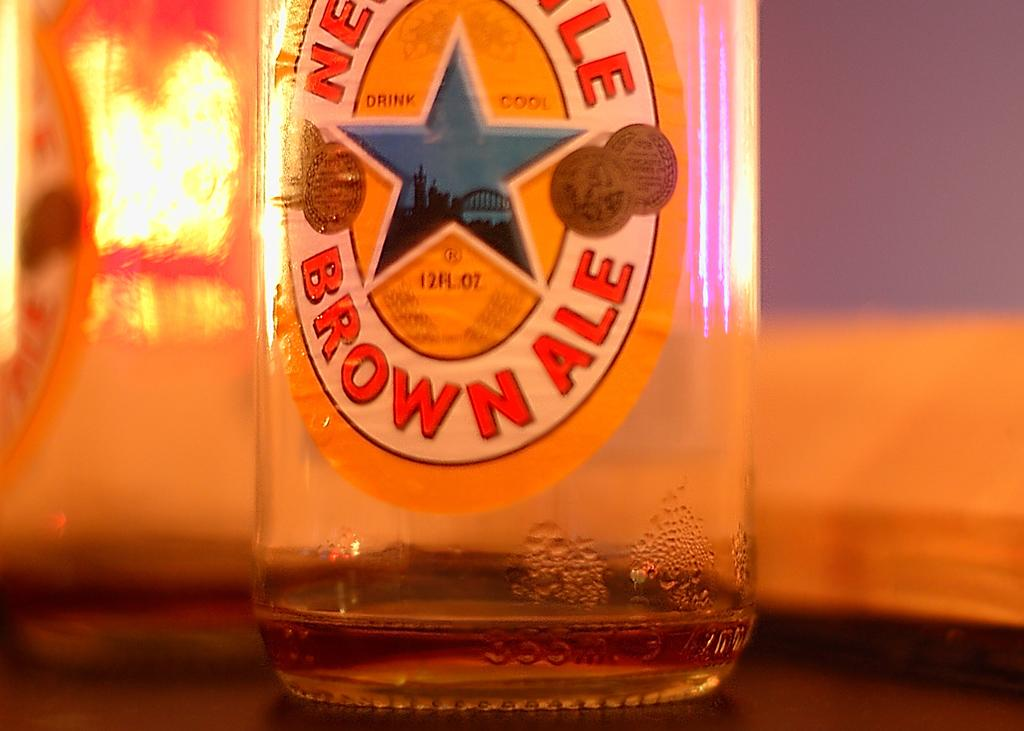<image>
Give a short and clear explanation of the subsequent image. A Brown Ale bottle has a blue star on the center of the label. 